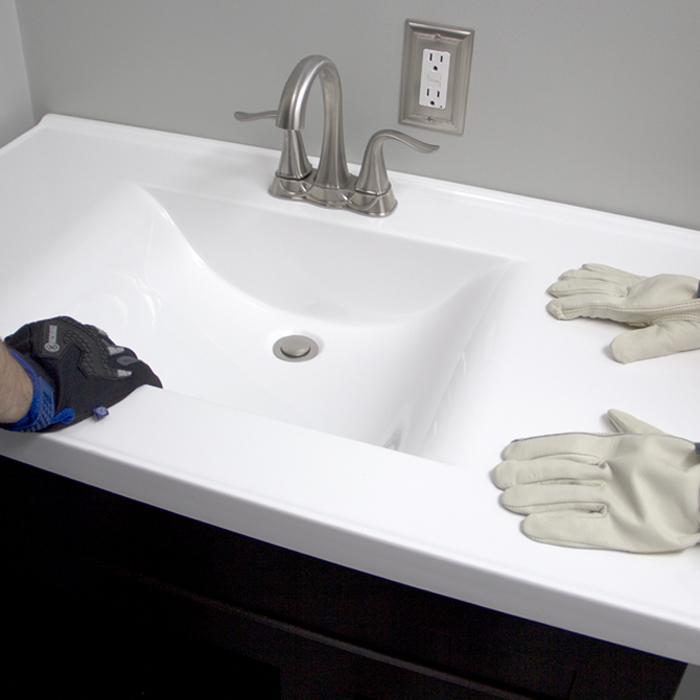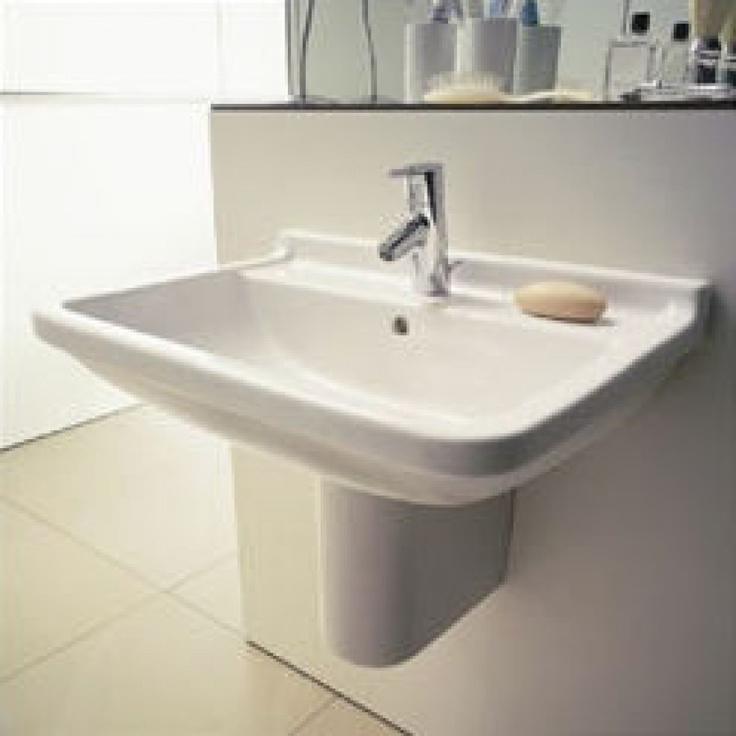The first image is the image on the left, the second image is the image on the right. Evaluate the accuracy of this statement regarding the images: "Exactly two bathroom sinks are shown, one with hot and cold water faucets, while the other has a single unright faucet.". Is it true? Answer yes or no. Yes. 